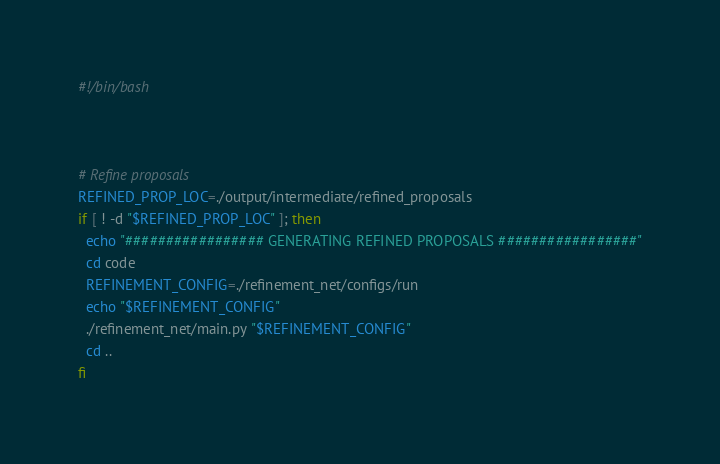Convert code to text. <code><loc_0><loc_0><loc_500><loc_500><_Bash_>#!/bin/bash



# Refine proposals
REFINED_PROP_LOC=./output/intermediate/refined_proposals
if [ ! -d "$REFINED_PROP_LOC" ]; then
  echo "################# GENERATING REFINED PROPOSALS #################"
  cd code
  REFINEMENT_CONFIG=./refinement_net/configs/run
  echo "$REFINEMENT_CONFIG"
  ./refinement_net/main.py "$REFINEMENT_CONFIG"
  cd ..
fi

</code> 